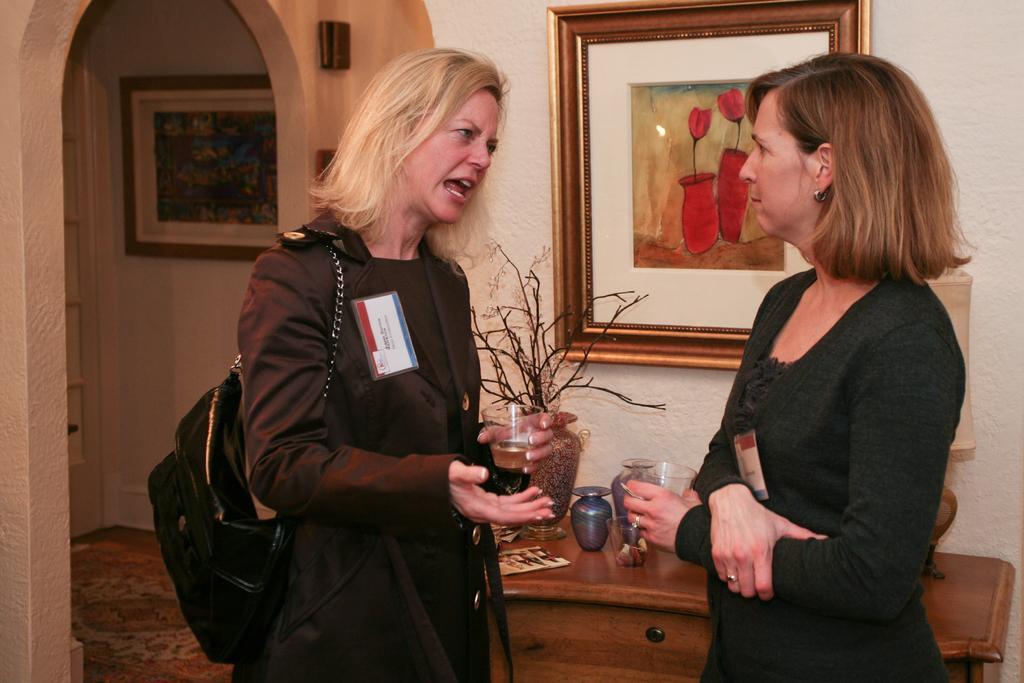Please provide a concise description of this image. In this image I can see 2 women standing in a room and talking to each other. There is a table at the back on which there is a plant pot and a lamp. There is a photo frame at the back. There is an arch on the left. There is a photo frame on the wall. 